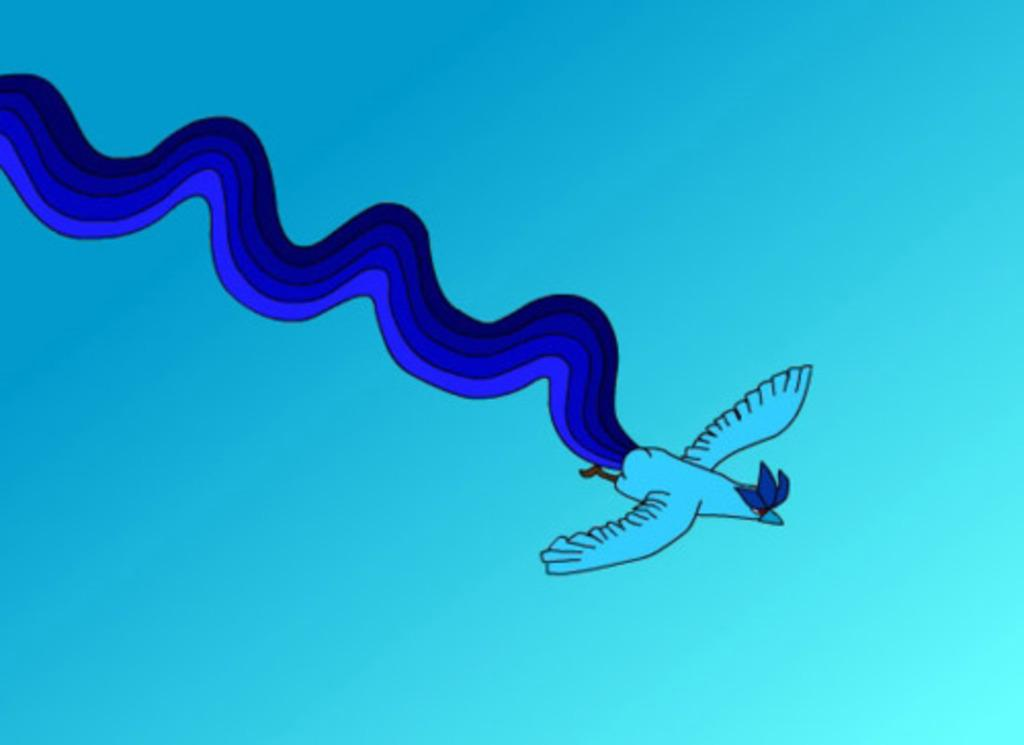What is present in the image? There is a bird in the image. What is the bird doing in the image? The bird is flying in the sky. Can you describe any specific features of the bird? The bird has a blue tail. What is the manager's role in the image? There is no manager present in the image, as it features a bird flying in the sky. 